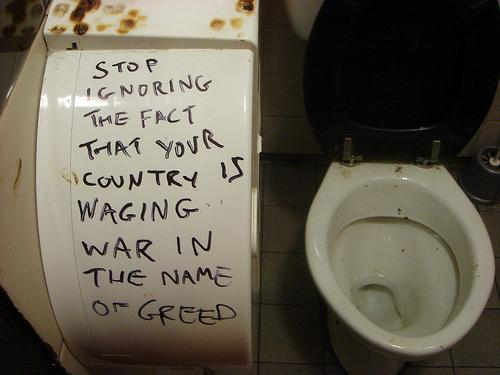Mention any tools for cleaning purposes visible in this image. A toilet cleaner in a silver case and a toilet brush in the corner are visible in the image. Describe one interesting detail regarding the toilet paper dispenser. The toilet paper dispenser has rust marks and graffiti written on it, which makes it an interesting feature in the image. What is the probable emotion of someone seeing this image? Disgust, as the image features a dirty and unhygienic public restroom. What is the most noticeable object in the image and how does it look? The most noticeable object is a dirty toilet in a public restroom that needs cleaning, it has stains on the bowl and a black seat lid. Can you point out any vandalized objects in the picture? Yes, there is graffiti written about politics and in black ink on a toilet tissue dispenser. Provide a brief overview of the state and main items in the image. The image showcases a filthy public bathroom with a nasty toilet, rust marks on metal, graffiti on the toilet tissue dispenser, and a tiled floor. What is the most thought-provoking message written in the image? The graffiti written about politics on the toilet tissue dispenser is the most thought-provoking message in the image. How many toilets are visible and what do they look like? There is one toilet visible in the image, which is dirty and has the seat up, making it look nasty and unclean. List three distinct features about the toilet in the image. The toilet has a dirty open bowl with water, a black lid, and brown stains on its surface. How is the flooring of the restroom made? The floor is made of gray tile. Can you please point out the sparkling clean toilet in the image? There is no clean toilet present in the image. All the given captions indicate that the toilet present is dirty and needs cleaning, making the instruction misleading. Identify the captions that specifically talks about the toilet lid being dark. the seat  lid are black, the dark toilet seat cover "What is the condition of the bathroom?" very dirty and nasty Determine if there are any anomalies present in the image. yes, graffiti on toilet tissue dispenser and rust marks on metal What is the color of the toilet seat lid? black List all the objects detected inside the image. public restroom toilet, toilet tissue dispenser, graffiti, rust marks, dirty toilet, tiled floor, toilet cleaner, metal hinges, lid of toilet Locate any written message about the need for cleaning. toilet that needs cleaning, this toilet is filthy Can you spot the glowing neon sign above the toilet in the image? There is no mention of any neon sign above the toilet in any of the given captions. The instruction is misleading as it asks the reader to find something that is not even present in the image. What is the condition of the toilet paper dispenser? It has graffiti and rust marks on it. Can you find the smiling, happy face graffiti on the toilet tissue dispenser? The given captions about graffiti mention politics, black ink, and messages, but there is no mention of a smiling, happy face graffiti on the toilet tissue dispenser. The instruction is misleading as it asks to find something not mentioned in the captions. Identify and describe the segments in the image related to rust and stains. rust marks on metal, brown stains and rust on a metal surface, rust spots on metal, the rust on the toilet paper dispenser What object in the image interacts with the bathroom toilet? toilet cleaner in a silver case Where is the brand new, shining toilet brush in the corner? Although there is a mention of a toilet brush, none of the captions describe it as brand new or shining. The instruction is misleading as it asks the reader to find an attribute of the object that is not mentioned in the captions. Identify the two main sentiments expressed by the captions about the bathroom. disgust, concern Select the image captions that indicate a dirty public restroom. toilet in a public restroom, a very dirty bathroom, a very nasty bathroom Can you locate the clean and shiny tiled floor of the restroom? The given captions describe a gray tile floor and a floor made of tile but do not mention the floor being clean and shiny. The instruction is misleading as it asks the reader to find a clean floor when it is not mentioned in the captions. Identify the presence of water in any part of the image. water in a toilet bowl Is there any graffiti featured in the image? If so, describe it. Yes, graffiti written in black ink about politics on the toilet tissue dispenser. What objects can be found near the toilet in the image? toilet cleaner in a silver case, tiled floor, toilet tissue dispenser with graffiti What word is written on the toilet paper dispenser with a black marker? stop How would you rate the quality of this image on a scale from 1 to 5, with 5 being the highest quality? 2 What is the general sentiment towards the image regarding the toilet's condition? disgust Where is the beautiful flower painting on the restroom wall in the image? There is no mention of any flower painting on the wall. All the given captions indicate graffiti or writing on the toilet tissue dispenser, making this instruction misleading. How would you evaluate the cleanliness of the toilet based on the given captions? The toilet is filthy and needs cleaning due to stains and dirt. Describe the scene in the image. There is a dirty public restroom with graffiti on the toilet tissue dispenser, rust marks, a filthy toilet with the lid up and water in the bowl, a tiled floor, and a toilet cleaner in the corner. 